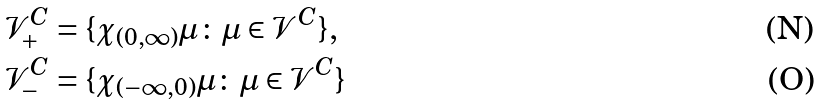Convert formula to latex. <formula><loc_0><loc_0><loc_500><loc_500>\mathcal { V } ^ { C } _ { + } & = \{ \chi _ { ( 0 , \infty ) } \mu \colon \mu \in \mathcal { V } ^ { C } \} , \\ \mathcal { V } ^ { C } _ { - } & = \{ \chi _ { ( - \infty , 0 ) } \mu \colon \mu \in \mathcal { V } ^ { C } \}</formula> 